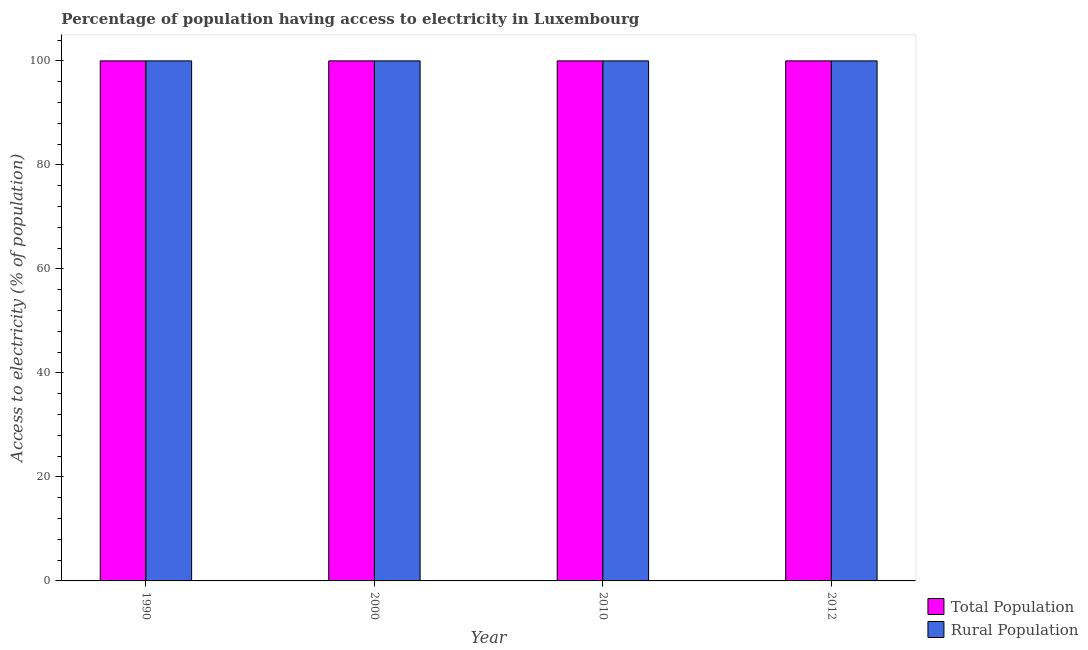How many different coloured bars are there?
Give a very brief answer. 2. How many groups of bars are there?
Your response must be concise. 4. Are the number of bars on each tick of the X-axis equal?
Make the answer very short. Yes. How many bars are there on the 4th tick from the left?
Your response must be concise. 2. How many bars are there on the 4th tick from the right?
Offer a very short reply. 2. What is the label of the 4th group of bars from the left?
Your answer should be very brief. 2012. What is the percentage of rural population having access to electricity in 2010?
Provide a short and direct response. 100. Across all years, what is the maximum percentage of population having access to electricity?
Give a very brief answer. 100. Across all years, what is the minimum percentage of rural population having access to electricity?
Give a very brief answer. 100. What is the total percentage of rural population having access to electricity in the graph?
Offer a terse response. 400. What is the difference between the percentage of rural population having access to electricity in 1990 and that in 2000?
Make the answer very short. 0. In how many years, is the percentage of rural population having access to electricity greater than 64 %?
Keep it short and to the point. 4. What is the ratio of the percentage of population having access to electricity in 1990 to that in 2010?
Your response must be concise. 1. What is the difference between the highest and the lowest percentage of rural population having access to electricity?
Ensure brevity in your answer.  0. In how many years, is the percentage of rural population having access to electricity greater than the average percentage of rural population having access to electricity taken over all years?
Your answer should be very brief. 0. Is the sum of the percentage of rural population having access to electricity in 2000 and 2010 greater than the maximum percentage of population having access to electricity across all years?
Your answer should be compact. Yes. What does the 2nd bar from the left in 1990 represents?
Ensure brevity in your answer.  Rural Population. What does the 2nd bar from the right in 2000 represents?
Your answer should be very brief. Total Population. How many bars are there?
Ensure brevity in your answer.  8. How many years are there in the graph?
Ensure brevity in your answer.  4. What is the difference between two consecutive major ticks on the Y-axis?
Offer a terse response. 20. Does the graph contain grids?
Your answer should be compact. No. What is the title of the graph?
Offer a very short reply. Percentage of population having access to electricity in Luxembourg. Does "Personal remittances" appear as one of the legend labels in the graph?
Offer a terse response. No. What is the label or title of the Y-axis?
Your response must be concise. Access to electricity (% of population). What is the Access to electricity (% of population) of Total Population in 2000?
Give a very brief answer. 100. What is the Access to electricity (% of population) of Rural Population in 2000?
Offer a very short reply. 100. What is the Access to electricity (% of population) of Total Population in 2010?
Keep it short and to the point. 100. What is the Access to electricity (% of population) of Rural Population in 2010?
Your answer should be compact. 100. What is the Access to electricity (% of population) in Rural Population in 2012?
Ensure brevity in your answer.  100. Across all years, what is the maximum Access to electricity (% of population) in Total Population?
Your answer should be compact. 100. Across all years, what is the minimum Access to electricity (% of population) of Total Population?
Keep it short and to the point. 100. Across all years, what is the minimum Access to electricity (% of population) of Rural Population?
Ensure brevity in your answer.  100. What is the total Access to electricity (% of population) of Total Population in the graph?
Offer a terse response. 400. What is the total Access to electricity (% of population) in Rural Population in the graph?
Offer a very short reply. 400. What is the difference between the Access to electricity (% of population) of Rural Population in 1990 and that in 2000?
Your answer should be very brief. 0. What is the difference between the Access to electricity (% of population) in Total Population in 1990 and that in 2010?
Make the answer very short. 0. What is the difference between the Access to electricity (% of population) of Rural Population in 1990 and that in 2010?
Keep it short and to the point. 0. What is the difference between the Access to electricity (% of population) in Total Population in 2010 and that in 2012?
Keep it short and to the point. 0. What is the difference between the Access to electricity (% of population) of Total Population in 1990 and the Access to electricity (% of population) of Rural Population in 2010?
Make the answer very short. 0. What is the difference between the Access to electricity (% of population) of Total Population in 1990 and the Access to electricity (% of population) of Rural Population in 2012?
Your answer should be very brief. 0. What is the difference between the Access to electricity (% of population) of Total Population in 2000 and the Access to electricity (% of population) of Rural Population in 2010?
Offer a terse response. 0. What is the difference between the Access to electricity (% of population) in Total Population in 2010 and the Access to electricity (% of population) in Rural Population in 2012?
Make the answer very short. 0. What is the average Access to electricity (% of population) of Total Population per year?
Offer a very short reply. 100. What is the average Access to electricity (% of population) in Rural Population per year?
Offer a terse response. 100. In the year 1990, what is the difference between the Access to electricity (% of population) in Total Population and Access to electricity (% of population) in Rural Population?
Provide a succinct answer. 0. In the year 2000, what is the difference between the Access to electricity (% of population) in Total Population and Access to electricity (% of population) in Rural Population?
Provide a succinct answer. 0. What is the ratio of the Access to electricity (% of population) in Total Population in 1990 to that in 2000?
Offer a terse response. 1. What is the ratio of the Access to electricity (% of population) in Total Population in 1990 to that in 2010?
Make the answer very short. 1. What is the ratio of the Access to electricity (% of population) of Total Population in 1990 to that in 2012?
Provide a succinct answer. 1. What is the ratio of the Access to electricity (% of population) of Total Population in 2000 to that in 2010?
Provide a succinct answer. 1. What is the difference between the highest and the lowest Access to electricity (% of population) of Total Population?
Keep it short and to the point. 0. 